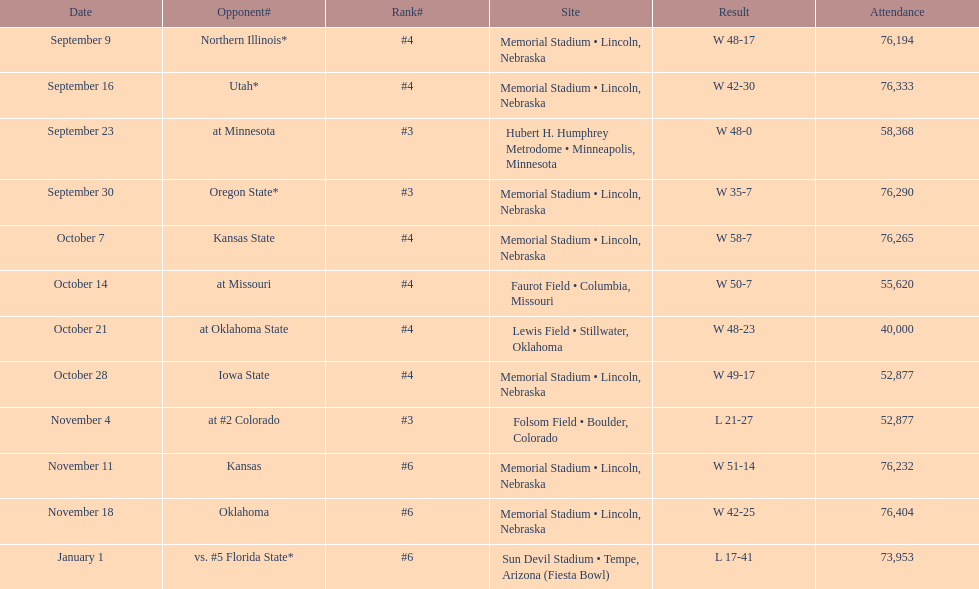Which month has the lowest frequency on this chart? January. 